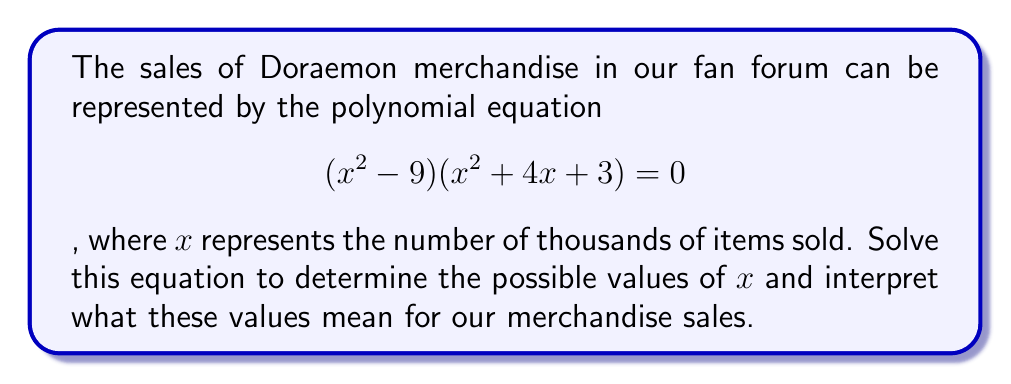Give your solution to this math problem. Let's solve this polynomial equation step by step:

1) The equation is in the form of a product equal to zero. This means that either $(x^2 - 9) = 0$ or $(x^2 + 4x + 3) = 0$.

2) Let's solve $(x^2 - 9) = 0$ first:
   $x^2 = 9$
   $x = \pm 3$
   So, $x = 3$ or $x = -3$

3) Now, let's solve $(x^2 + 4x + 3) = 0$:
   This is a quadratic equation. We can solve it using the quadratic formula:
   $x = \frac{-b \pm \sqrt{b^2 - 4ac}}{2a}$
   Where $a = 1$, $b = 4$, and $c = 3$

   $x = \frac{-4 \pm \sqrt{16 - 12}}{2} = \frac{-4 \pm \sqrt{4}}{2} = \frac{-4 \pm 2}{2}$

   $x = -3$ or $x = -1$

4) Combining the results, we have four solutions: $x = 3$, $x = -3$, $x = -1$, and $x = -3$ (repeated).

5) Interpretation:
   - $x = 3$ means 3,000 items sold (positive and realistic)
   - $x = -3$ (repeated solution) and $x = -1$ are negative and don't make sense in the context of sales

Therefore, the only meaningful solution is $x = 3$, indicating that 3,000 items were sold.
Answer: $x = 3$, representing 3,000 items sold 